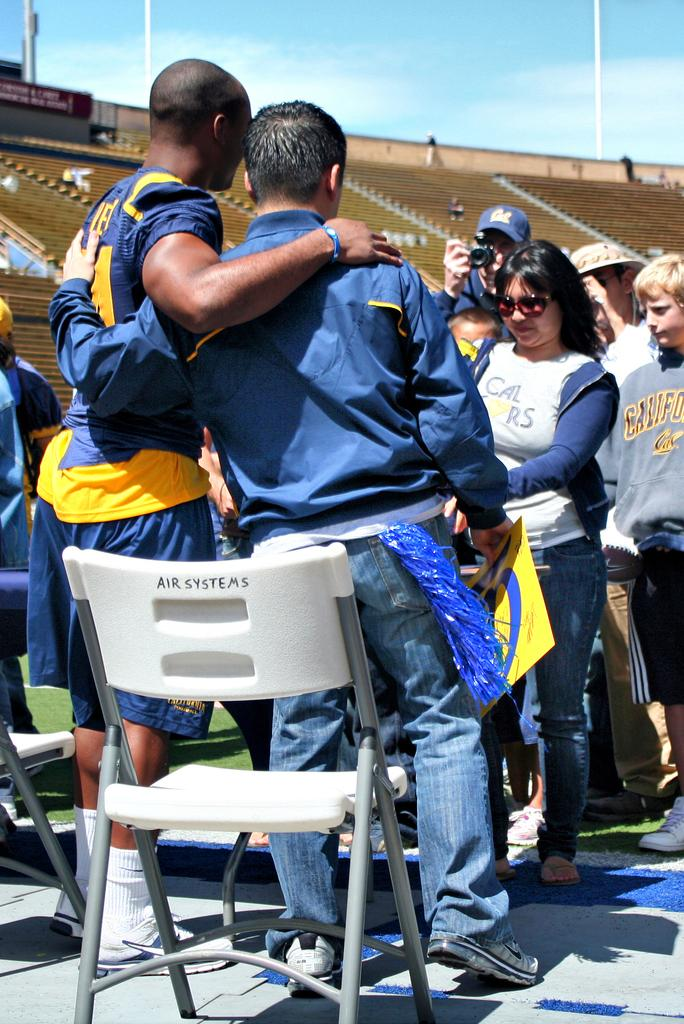What is the main setting of the image? The main setting of the image is a stadium. What can be seen in the background of the image? The sky is visible in the background of the image, and it is clear. What are the people in the image doing? The provided facts do not specify what the people are doing, but they are standing in the stadium. What type of drum can be seen hanging from the ceiling in the image? There is no drum present in the image; it features people standing in a stadium with a clear sky in the background. 